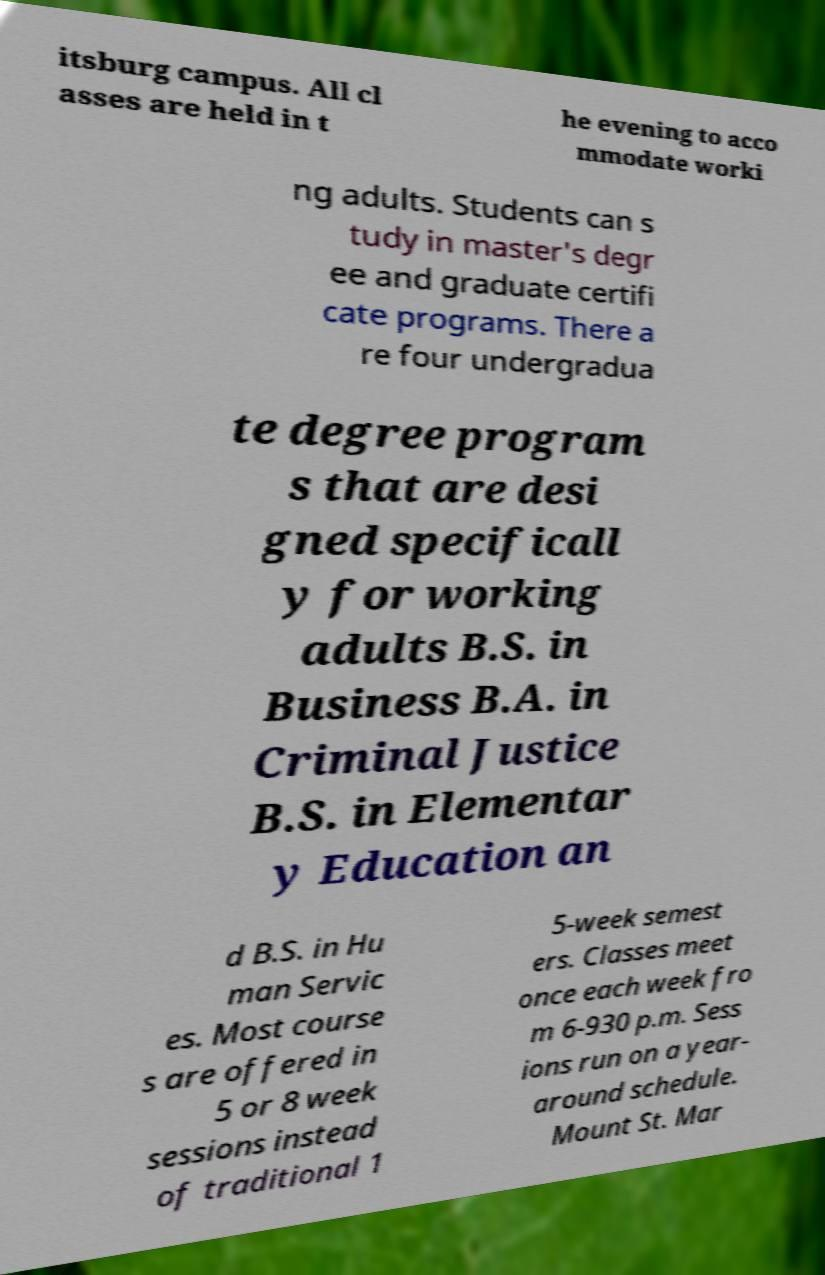Please identify and transcribe the text found in this image. itsburg campus. All cl asses are held in t he evening to acco mmodate worki ng adults. Students can s tudy in master's degr ee and graduate certifi cate programs. There a re four undergradua te degree program s that are desi gned specificall y for working adults B.S. in Business B.A. in Criminal Justice B.S. in Elementar y Education an d B.S. in Hu man Servic es. Most course s are offered in 5 or 8 week sessions instead of traditional 1 5-week semest ers. Classes meet once each week fro m 6-930 p.m. Sess ions run on a year- around schedule. Mount St. Mar 